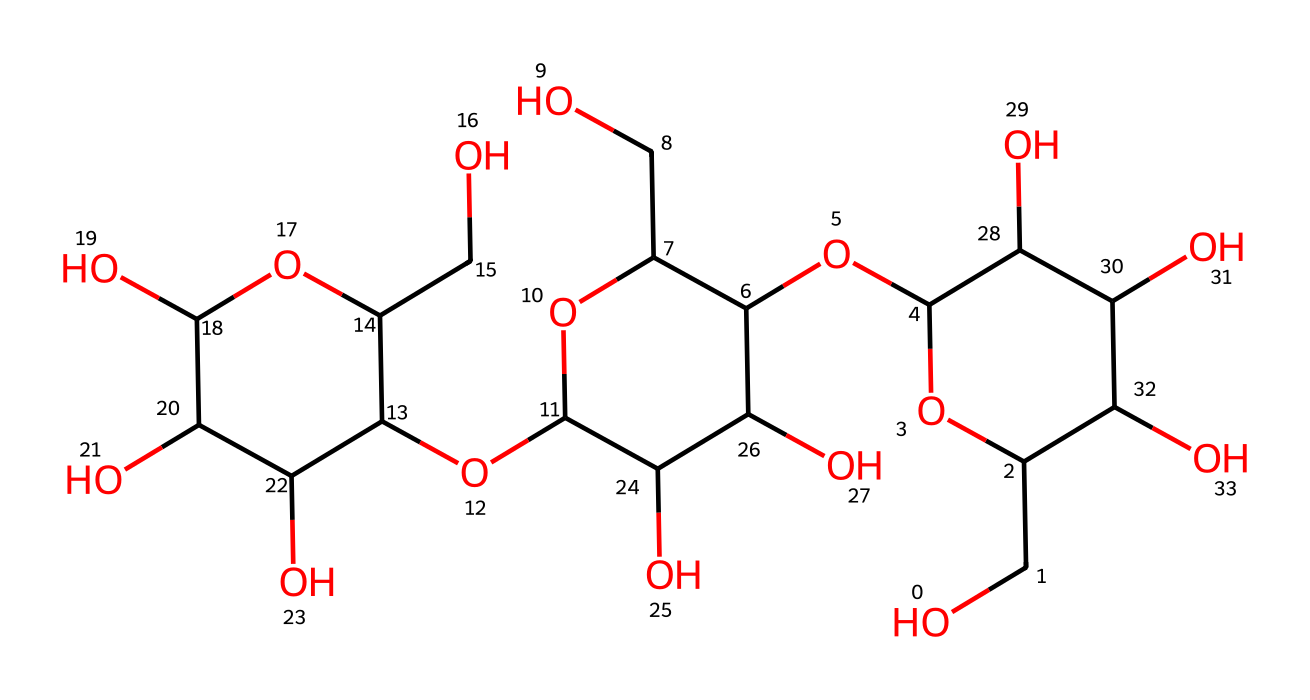how many carbon atoms are in the cellulose fiber structure? The SMILES notation indicates that there are several carbon atoms. By analyzing the string, we can identify all the 'C' symbols which represent carbon atoms. Counting each occurrence, we find there are 18 carbon atoms in the structure.
Answer: 18 how many hydroxyl groups are present in the chemical structure? Hydroxyl groups are indicated by the presence of 'O' atoms bonded to 'H' in the structure. By careful examination of the SMILES representation, we can count the number of -OH groups, which totals to 6.
Answer: 6 what type of polymer is cellulose? Cellulose is characterized as a polysaccharide, which is a type of polymer formed from multiple sugar units. This is evident from the repeating structure revealed in the chemical formulation.
Answer: polysaccharide what is the primary functional group in cellulose fibers? The primary functional group present in cellulose fibers is the hydroxyl (-OH) group, which significantly influences cellulose's properties such as hydrophilicity and reactivity. This can be seen from the numerous oxygen atoms that bond with hydrogen throughout the structure.
Answer: hydroxyl group how does the branching in cellulose fibers affect its properties? Cellulose has a relatively linear structure with limited branching, which provides high tensile strength and rigidity. This structural feature can be identified from the arrangement in the SMILES notation, indicating its suitability for textiles like sports towels.
Answer: high tensile strength what physical property of cellulose contributes to its use in sports towels? The presence of numerous hydroxyl groups enhances cellulose's ability to absorb moisture, making it highly effective as a material for sports towels. This can be deduced from the functional groups present in the structure that promote hydrophilicity.
Answer: moisture absorption 